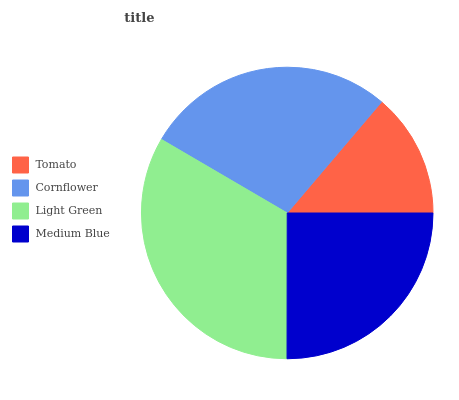Is Tomato the minimum?
Answer yes or no. Yes. Is Light Green the maximum?
Answer yes or no. Yes. Is Cornflower the minimum?
Answer yes or no. No. Is Cornflower the maximum?
Answer yes or no. No. Is Cornflower greater than Tomato?
Answer yes or no. Yes. Is Tomato less than Cornflower?
Answer yes or no. Yes. Is Tomato greater than Cornflower?
Answer yes or no. No. Is Cornflower less than Tomato?
Answer yes or no. No. Is Cornflower the high median?
Answer yes or no. Yes. Is Medium Blue the low median?
Answer yes or no. Yes. Is Light Green the high median?
Answer yes or no. No. Is Tomato the low median?
Answer yes or no. No. 